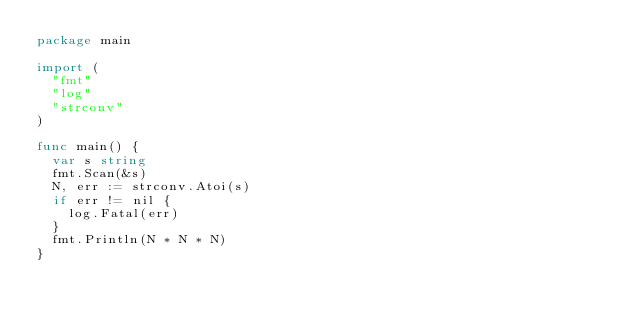Convert code to text. <code><loc_0><loc_0><loc_500><loc_500><_Go_>package main

import (
	"fmt"
	"log"
	"strconv"
)

func main() {
	var s string
	fmt.Scan(&s)
	N, err := strconv.Atoi(s)
	if err != nil {
		log.Fatal(err)
	}
	fmt.Println(N * N * N)
}
</code> 